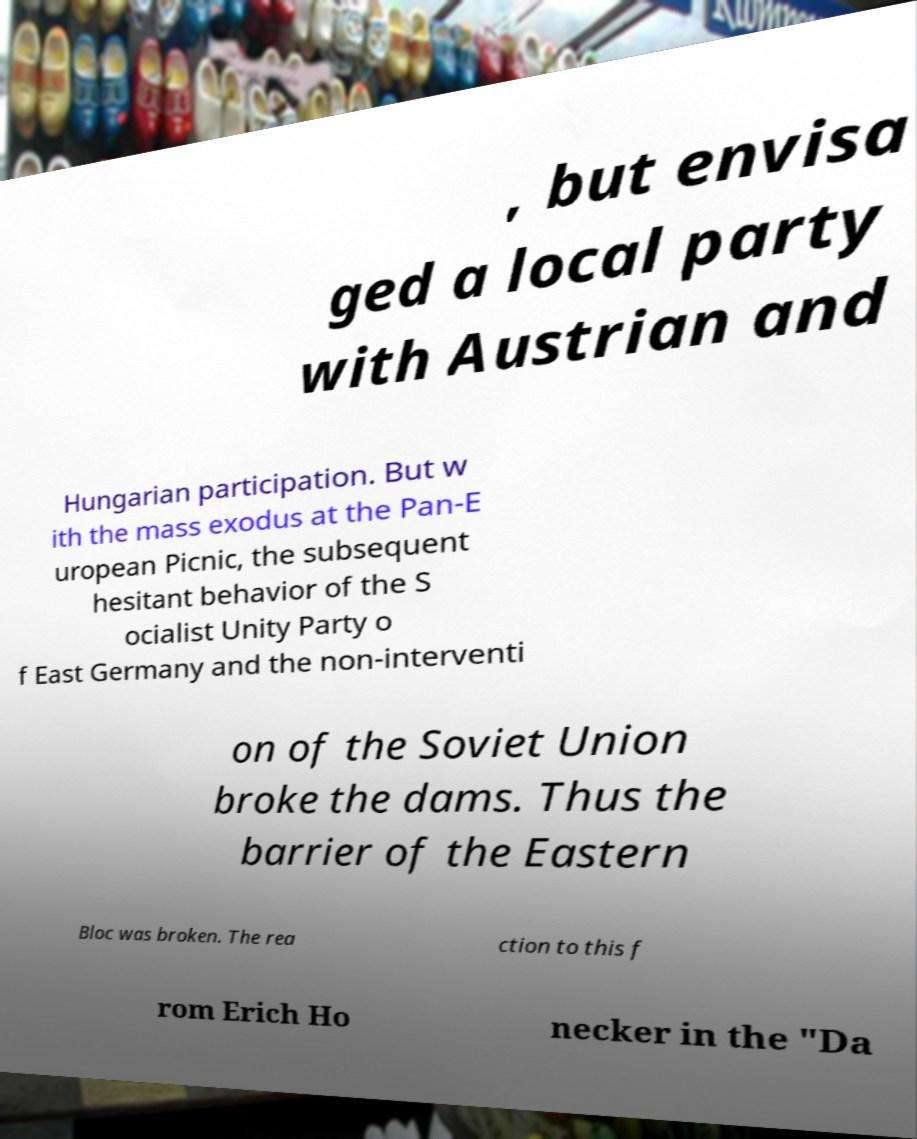Could you extract and type out the text from this image? , but envisa ged a local party with Austrian and Hungarian participation. But w ith the mass exodus at the Pan-E uropean Picnic, the subsequent hesitant behavior of the S ocialist Unity Party o f East Germany and the non-interventi on of the Soviet Union broke the dams. Thus the barrier of the Eastern Bloc was broken. The rea ction to this f rom Erich Ho necker in the "Da 